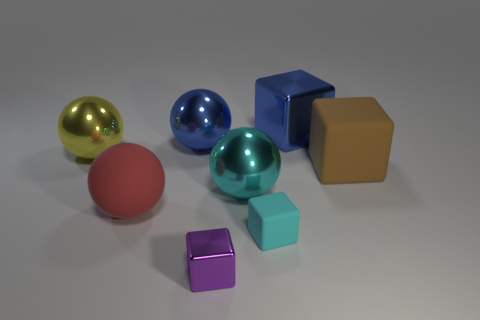Subtract all large red matte spheres. How many spheres are left? 3 Subtract 1 cubes. How many cubes are left? 3 Subtract all gray spheres. Subtract all purple cylinders. How many spheres are left? 4 Add 1 big cyan objects. How many objects exist? 9 Add 7 big gray metallic objects. How many big gray metallic objects exist? 7 Subtract 0 purple cylinders. How many objects are left? 8 Subtract all big brown metal objects. Subtract all rubber spheres. How many objects are left? 7 Add 5 yellow things. How many yellow things are left? 6 